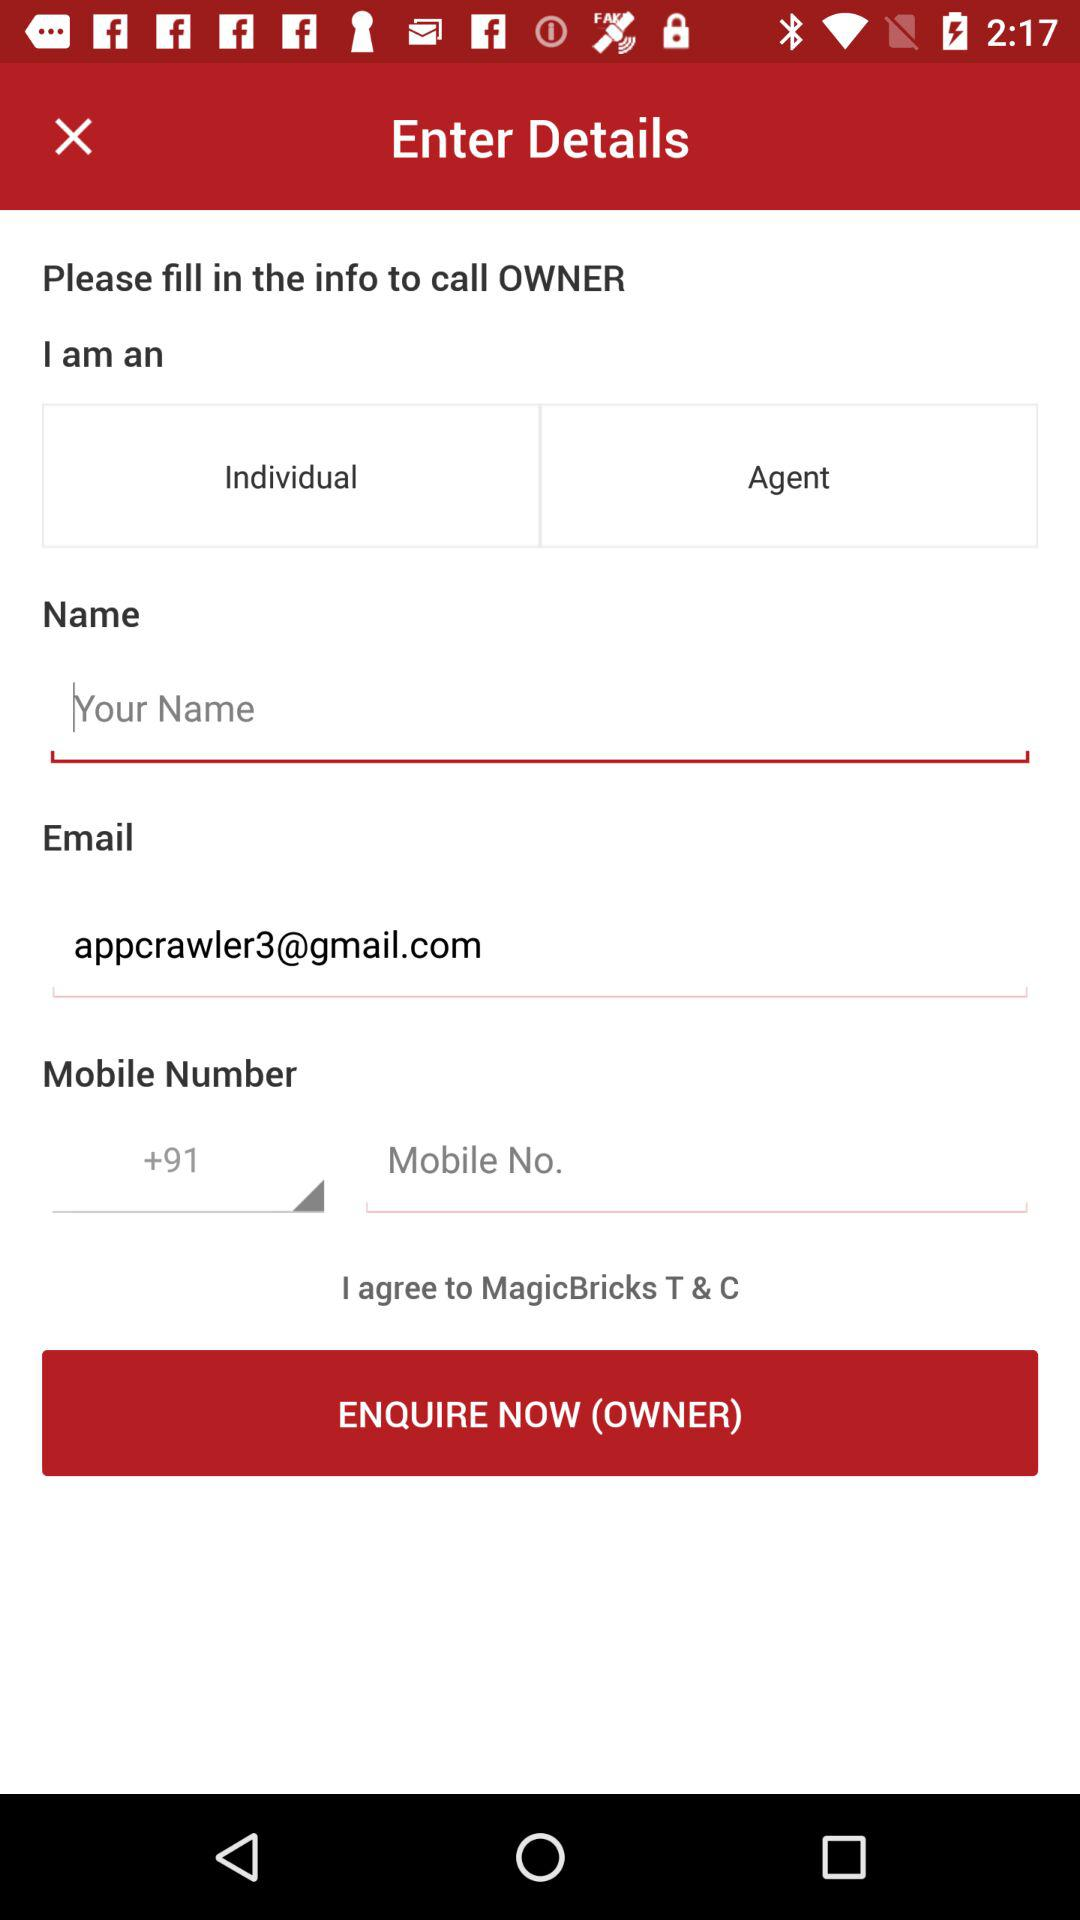How many text inputs are there for the owner to fill in?
Answer the question using a single word or phrase. 3 